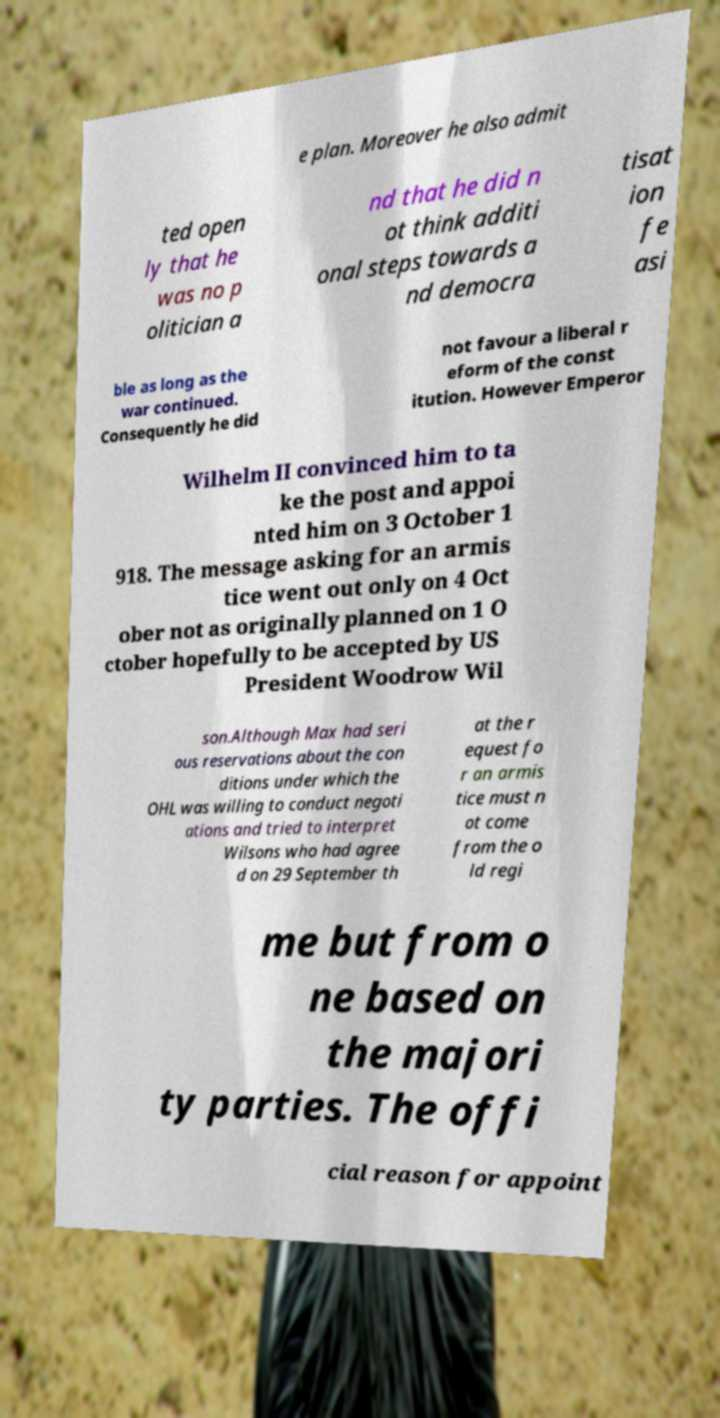There's text embedded in this image that I need extracted. Can you transcribe it verbatim? e plan. Moreover he also admit ted open ly that he was no p olitician a nd that he did n ot think additi onal steps towards a nd democra tisat ion fe asi ble as long as the war continued. Consequently he did not favour a liberal r eform of the const itution. However Emperor Wilhelm II convinced him to ta ke the post and appoi nted him on 3 October 1 918. The message asking for an armis tice went out only on 4 Oct ober not as originally planned on 1 O ctober hopefully to be accepted by US President Woodrow Wil son.Although Max had seri ous reservations about the con ditions under which the OHL was willing to conduct negoti ations and tried to interpret Wilsons who had agree d on 29 September th at the r equest fo r an armis tice must n ot come from the o ld regi me but from o ne based on the majori ty parties. The offi cial reason for appoint 